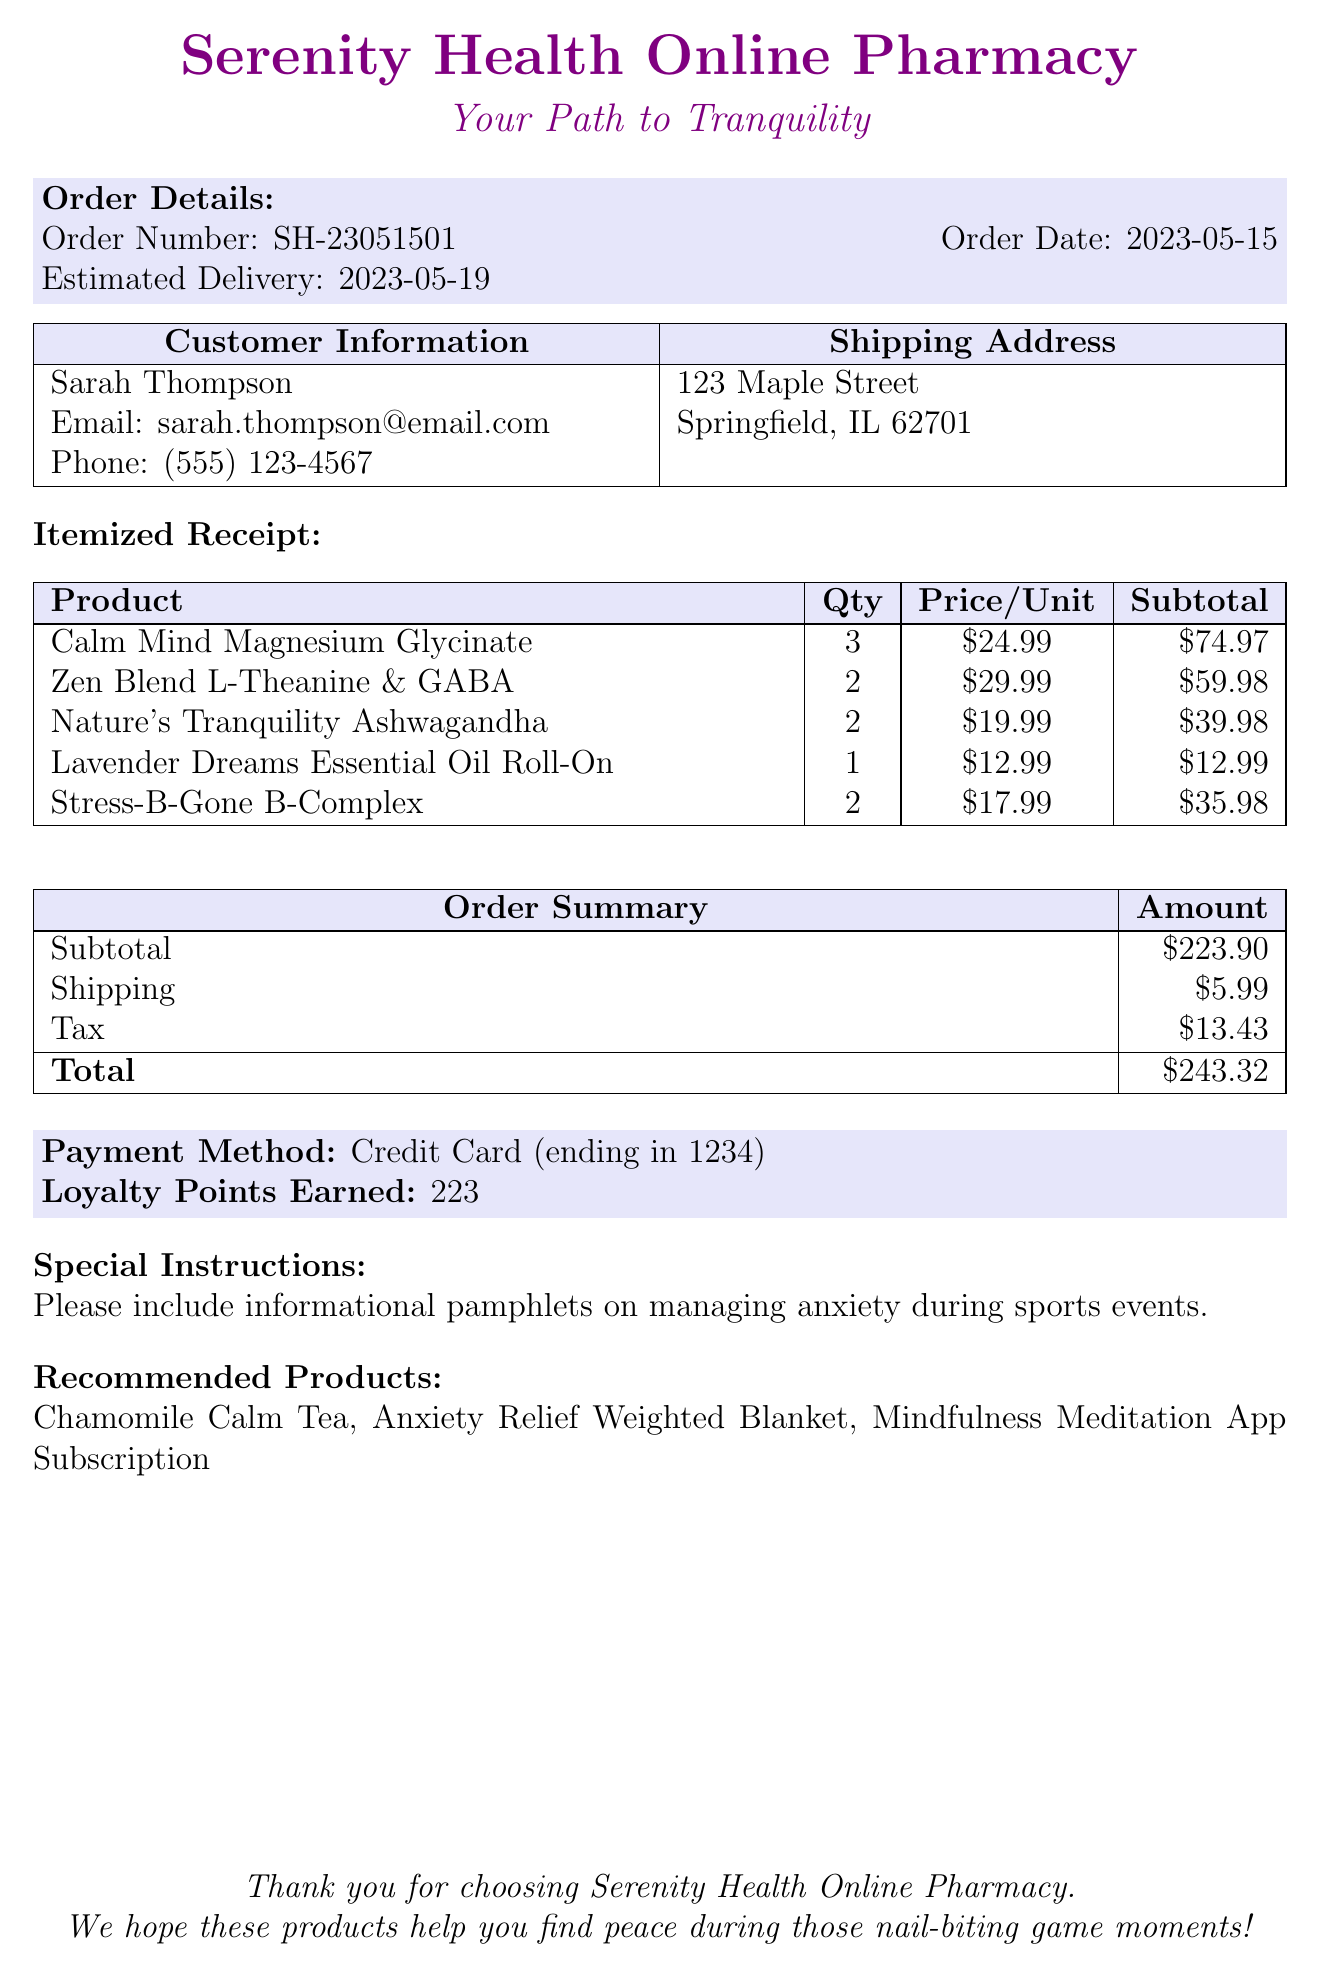What is the order date? The order date is explicitly mentioned as 2023-05-15.
Answer: 2023-05-15 What is the total amount of the order? The total amount is found in the order summary and is listed as $243.32.
Answer: $243.32 How many loyalty points were earned? The loyalty points earned are specified in the document as 223.
Answer: 223 Who is the customer? The customer's name is provided in the customer information section, which is Sarah Thompson.
Answer: Sarah Thompson What shipping address is listed? The shipping address is detailed in the document, showing the street, city, state, and zip code.
Answer: 123 Maple Street, Springfield, IL 62701 How many items were purchased in total? The total number of items purchased is the sum of all quantities in the itemized list, which is 3 + 2 + 2 + 1 + 2 = 10.
Answer: 10 What special instructions were included? The document states specific instructions regarding the inclusion of informational pamphlets on managing anxiety.
Answer: Please include informational pamphlets on managing anxiety during sports events What product had the highest unit price? By comparing the prices per unit in the itemized list, Zen Blend L-Theanine & GABA at $29.99 is the highest price.
Answer: Zen Blend L-Theanine & GABA What type of payment method was used? The payment method information indicates it was by Credit Card.
Answer: Credit Card 